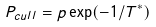<formula> <loc_0><loc_0><loc_500><loc_500>P _ { c u l l } = p \exp ( - 1 / T ^ { * } )</formula> 